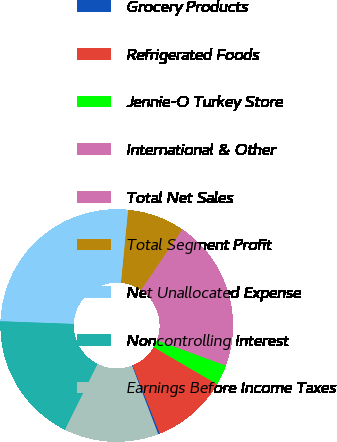Convert chart. <chart><loc_0><loc_0><loc_500><loc_500><pie_chart><fcel>Grocery Products<fcel>Refrigerated Foods<fcel>Jennie-O Turkey Store<fcel>International & Other<fcel>Total Net Sales<fcel>Total Segment Profit<fcel>Net Unallocated Expense<fcel>Noncontrolling Interest<fcel>Earnings Before Income Taxes<nl><fcel>0.25%<fcel>10.54%<fcel>2.82%<fcel>15.68%<fcel>5.39%<fcel>7.97%<fcel>25.97%<fcel>18.26%<fcel>13.11%<nl></chart> 